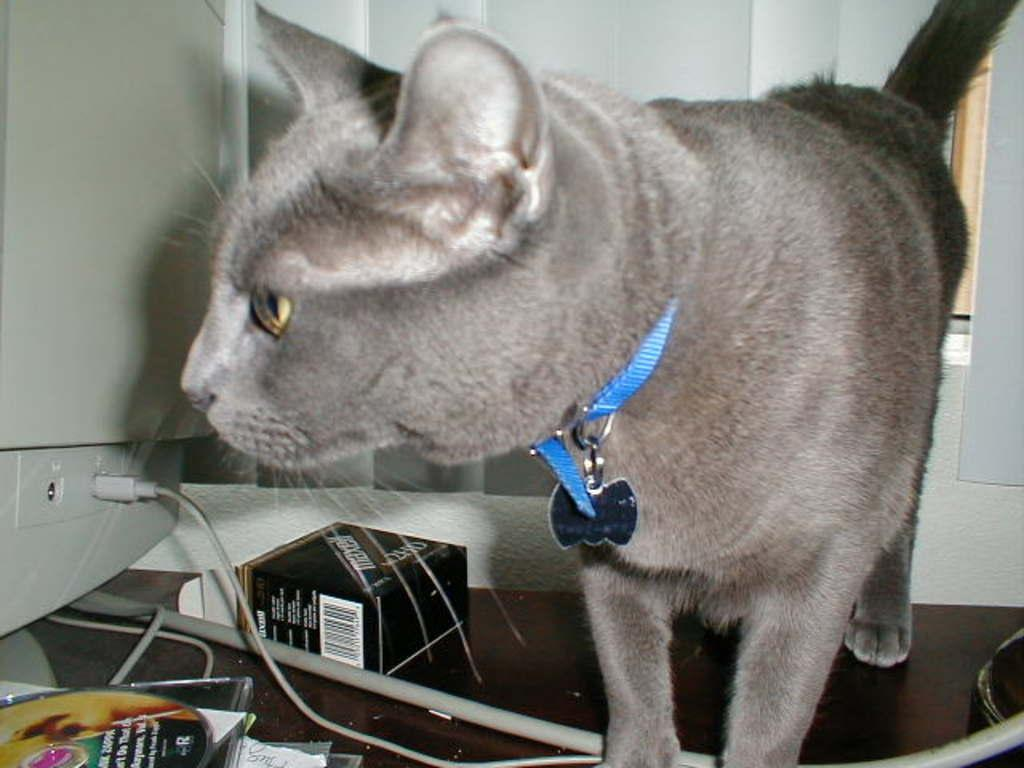What is the main object in the center of the image? There is a table in the center of the image. What electronic device is on the table? There is a monitor on the table. What other items can be seen on the table? There is a box, a CD, a paper, and a cat on the table. Can you describe the cat in the image? The cat is ash-colored and is on the table. What can be seen in the background of the image? There is a wall and a window in the background of the image. How many chickens are wearing skirts in the image? There are no chickens or skirts present in the image. What type of party is being held in the image? There is no party depicted in the image. 